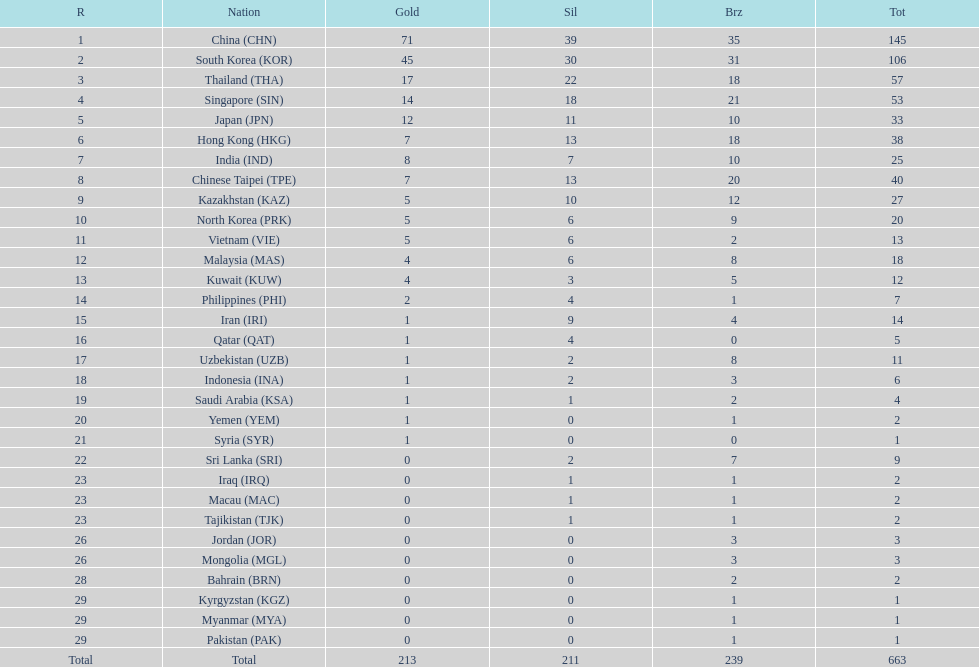Which countries have the same number of silver medals in the asian youth games as north korea? Vietnam (VIE), Malaysia (MAS). 